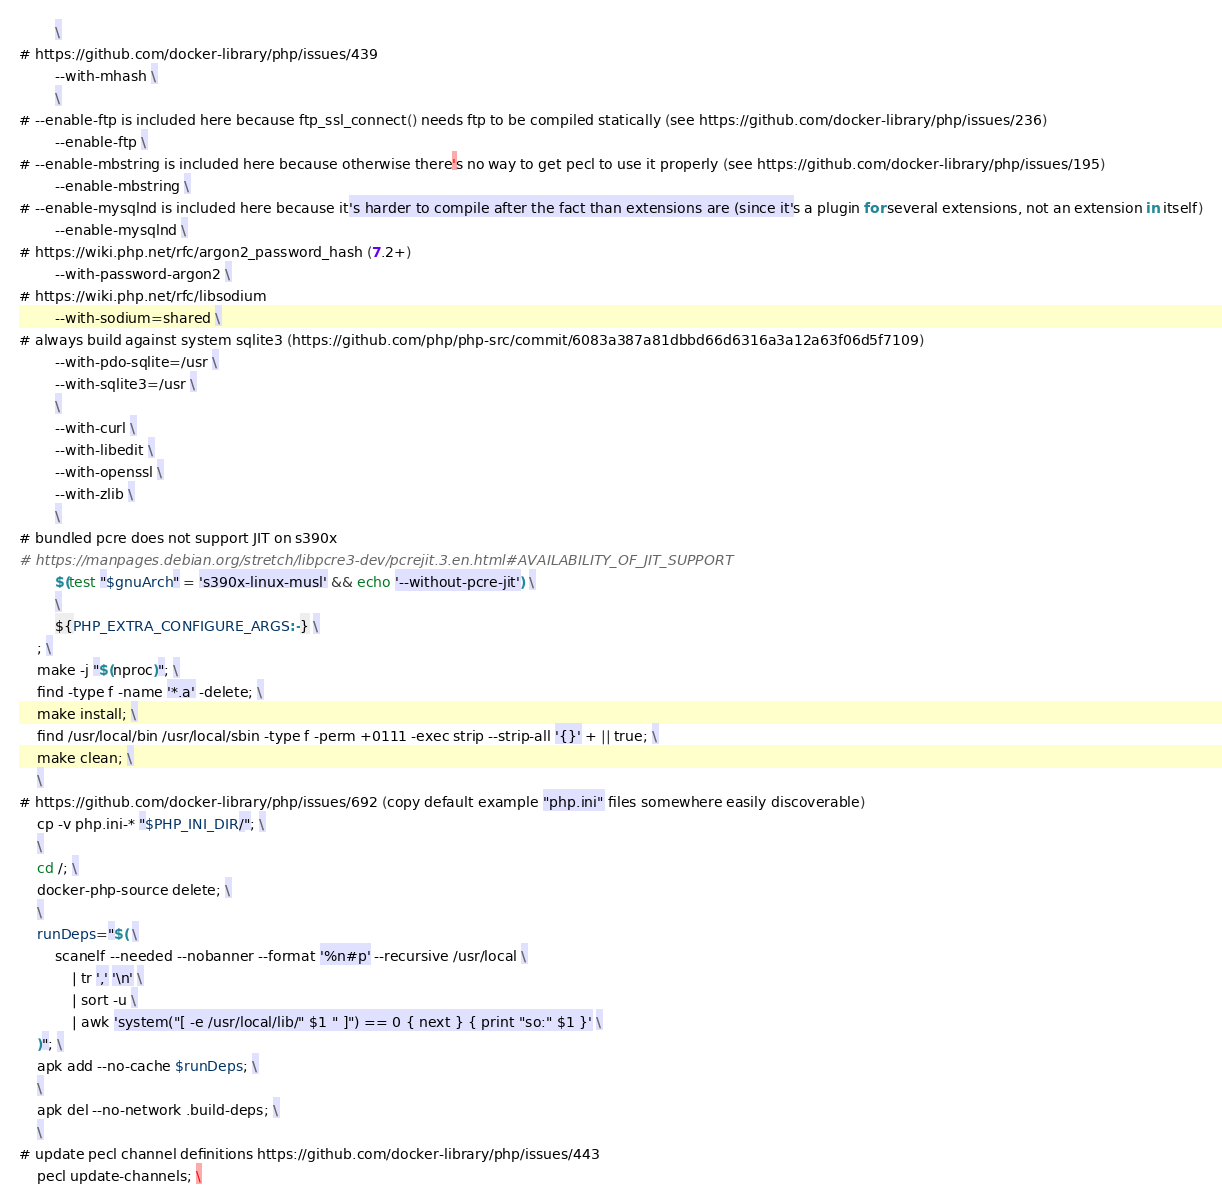<code> <loc_0><loc_0><loc_500><loc_500><_Dockerfile_>		\
# https://github.com/docker-library/php/issues/439
		--with-mhash \
		\
# --enable-ftp is included here because ftp_ssl_connect() needs ftp to be compiled statically (see https://github.com/docker-library/php/issues/236)
		--enable-ftp \
# --enable-mbstring is included here because otherwise there's no way to get pecl to use it properly (see https://github.com/docker-library/php/issues/195)
		--enable-mbstring \
# --enable-mysqlnd is included here because it's harder to compile after the fact than extensions are (since it's a plugin for several extensions, not an extension in itself)
		--enable-mysqlnd \
# https://wiki.php.net/rfc/argon2_password_hash (7.2+)
		--with-password-argon2 \
# https://wiki.php.net/rfc/libsodium
		--with-sodium=shared \
# always build against system sqlite3 (https://github.com/php/php-src/commit/6083a387a81dbbd66d6316a3a12a63f06d5f7109)
		--with-pdo-sqlite=/usr \
		--with-sqlite3=/usr \
		\
		--with-curl \
		--with-libedit \
		--with-openssl \
		--with-zlib \
		\
# bundled pcre does not support JIT on s390x
# https://manpages.debian.org/stretch/libpcre3-dev/pcrejit.3.en.html#AVAILABILITY_OF_JIT_SUPPORT
		$(test "$gnuArch" = 's390x-linux-musl' && echo '--without-pcre-jit') \
		\
		${PHP_EXTRA_CONFIGURE_ARGS:-} \
	; \
	make -j "$(nproc)"; \
	find -type f -name '*.a' -delete; \
	make install; \
	find /usr/local/bin /usr/local/sbin -type f -perm +0111 -exec strip --strip-all '{}' + || true; \
	make clean; \
	\
# https://github.com/docker-library/php/issues/692 (copy default example "php.ini" files somewhere easily discoverable)
	cp -v php.ini-* "$PHP_INI_DIR/"; \
	\
	cd /; \
	docker-php-source delete; \
	\
	runDeps="$( \
		scanelf --needed --nobanner --format '%n#p' --recursive /usr/local \
			| tr ',' '\n' \
			| sort -u \
			| awk 'system("[ -e /usr/local/lib/" $1 " ]") == 0 { next } { print "so:" $1 }' \
	)"; \
	apk add --no-cache $runDeps; \
	\
	apk del --no-network .build-deps; \
	\
# update pecl channel definitions https://github.com/docker-library/php/issues/443
	pecl update-channels; \</code> 